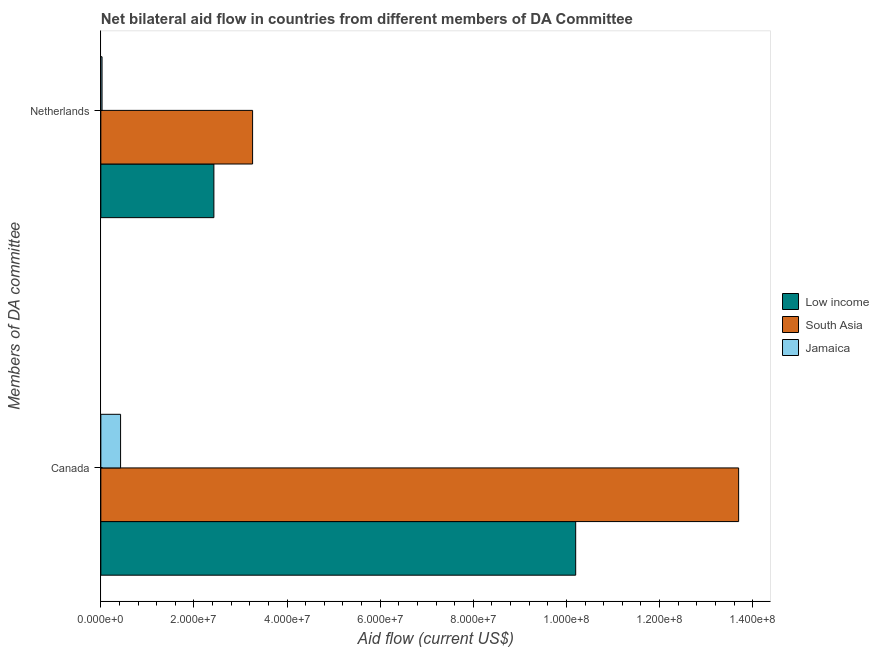How many bars are there on the 2nd tick from the top?
Keep it short and to the point. 3. What is the label of the 2nd group of bars from the top?
Your answer should be compact. Canada. What is the amount of aid given by netherlands in Jamaica?
Your answer should be very brief. 2.60e+05. Across all countries, what is the maximum amount of aid given by netherlands?
Your response must be concise. 3.26e+07. Across all countries, what is the minimum amount of aid given by netherlands?
Offer a terse response. 2.60e+05. In which country was the amount of aid given by netherlands maximum?
Offer a very short reply. South Asia. In which country was the amount of aid given by canada minimum?
Offer a very short reply. Jamaica. What is the total amount of aid given by canada in the graph?
Provide a short and direct response. 2.43e+08. What is the difference between the amount of aid given by canada in South Asia and that in Low income?
Provide a succinct answer. 3.50e+07. What is the difference between the amount of aid given by netherlands in Low income and the amount of aid given by canada in Jamaica?
Your answer should be compact. 2.00e+07. What is the average amount of aid given by canada per country?
Provide a short and direct response. 8.11e+07. What is the difference between the amount of aid given by netherlands and amount of aid given by canada in Jamaica?
Offer a very short reply. -3.98e+06. What is the ratio of the amount of aid given by netherlands in Low income to that in South Asia?
Keep it short and to the point. 0.75. Is the amount of aid given by netherlands in Jamaica less than that in South Asia?
Ensure brevity in your answer.  Yes. How many countries are there in the graph?
Your answer should be compact. 3. Are the values on the major ticks of X-axis written in scientific E-notation?
Provide a succinct answer. Yes. Does the graph contain grids?
Your answer should be compact. No. Where does the legend appear in the graph?
Your answer should be very brief. Center right. How are the legend labels stacked?
Ensure brevity in your answer.  Vertical. What is the title of the graph?
Your response must be concise. Net bilateral aid flow in countries from different members of DA Committee. Does "Arab World" appear as one of the legend labels in the graph?
Offer a very short reply. No. What is the label or title of the Y-axis?
Ensure brevity in your answer.  Members of DA committee. What is the Aid flow (current US$) in Low income in Canada?
Ensure brevity in your answer.  1.02e+08. What is the Aid flow (current US$) of South Asia in Canada?
Offer a very short reply. 1.37e+08. What is the Aid flow (current US$) of Jamaica in Canada?
Your answer should be compact. 4.24e+06. What is the Aid flow (current US$) of Low income in Netherlands?
Ensure brevity in your answer.  2.43e+07. What is the Aid flow (current US$) in South Asia in Netherlands?
Offer a terse response. 3.26e+07. Across all Members of DA committee, what is the maximum Aid flow (current US$) of Low income?
Keep it short and to the point. 1.02e+08. Across all Members of DA committee, what is the maximum Aid flow (current US$) of South Asia?
Offer a terse response. 1.37e+08. Across all Members of DA committee, what is the maximum Aid flow (current US$) of Jamaica?
Provide a succinct answer. 4.24e+06. Across all Members of DA committee, what is the minimum Aid flow (current US$) of Low income?
Give a very brief answer. 2.43e+07. Across all Members of DA committee, what is the minimum Aid flow (current US$) of South Asia?
Provide a short and direct response. 3.26e+07. Across all Members of DA committee, what is the minimum Aid flow (current US$) of Jamaica?
Your response must be concise. 2.60e+05. What is the total Aid flow (current US$) in Low income in the graph?
Keep it short and to the point. 1.26e+08. What is the total Aid flow (current US$) of South Asia in the graph?
Make the answer very short. 1.70e+08. What is the total Aid flow (current US$) of Jamaica in the graph?
Make the answer very short. 4.50e+06. What is the difference between the Aid flow (current US$) in Low income in Canada and that in Netherlands?
Provide a succinct answer. 7.77e+07. What is the difference between the Aid flow (current US$) in South Asia in Canada and that in Netherlands?
Provide a short and direct response. 1.04e+08. What is the difference between the Aid flow (current US$) of Jamaica in Canada and that in Netherlands?
Give a very brief answer. 3.98e+06. What is the difference between the Aid flow (current US$) in Low income in Canada and the Aid flow (current US$) in South Asia in Netherlands?
Offer a terse response. 6.94e+07. What is the difference between the Aid flow (current US$) of Low income in Canada and the Aid flow (current US$) of Jamaica in Netherlands?
Offer a very short reply. 1.02e+08. What is the difference between the Aid flow (current US$) of South Asia in Canada and the Aid flow (current US$) of Jamaica in Netherlands?
Offer a very short reply. 1.37e+08. What is the average Aid flow (current US$) in Low income per Members of DA committee?
Ensure brevity in your answer.  6.31e+07. What is the average Aid flow (current US$) of South Asia per Members of DA committee?
Ensure brevity in your answer.  8.48e+07. What is the average Aid flow (current US$) in Jamaica per Members of DA committee?
Offer a terse response. 2.25e+06. What is the difference between the Aid flow (current US$) of Low income and Aid flow (current US$) of South Asia in Canada?
Your response must be concise. -3.50e+07. What is the difference between the Aid flow (current US$) of Low income and Aid flow (current US$) of Jamaica in Canada?
Offer a terse response. 9.77e+07. What is the difference between the Aid flow (current US$) of South Asia and Aid flow (current US$) of Jamaica in Canada?
Ensure brevity in your answer.  1.33e+08. What is the difference between the Aid flow (current US$) of Low income and Aid flow (current US$) of South Asia in Netherlands?
Offer a very short reply. -8.31e+06. What is the difference between the Aid flow (current US$) of Low income and Aid flow (current US$) of Jamaica in Netherlands?
Offer a terse response. 2.40e+07. What is the difference between the Aid flow (current US$) in South Asia and Aid flow (current US$) in Jamaica in Netherlands?
Ensure brevity in your answer.  3.23e+07. What is the ratio of the Aid flow (current US$) in Low income in Canada to that in Netherlands?
Ensure brevity in your answer.  4.2. What is the ratio of the Aid flow (current US$) of South Asia in Canada to that in Netherlands?
Make the answer very short. 4.2. What is the ratio of the Aid flow (current US$) in Jamaica in Canada to that in Netherlands?
Your answer should be compact. 16.31. What is the difference between the highest and the second highest Aid flow (current US$) of Low income?
Ensure brevity in your answer.  7.77e+07. What is the difference between the highest and the second highest Aid flow (current US$) in South Asia?
Ensure brevity in your answer.  1.04e+08. What is the difference between the highest and the second highest Aid flow (current US$) of Jamaica?
Your answer should be compact. 3.98e+06. What is the difference between the highest and the lowest Aid flow (current US$) in Low income?
Give a very brief answer. 7.77e+07. What is the difference between the highest and the lowest Aid flow (current US$) of South Asia?
Make the answer very short. 1.04e+08. What is the difference between the highest and the lowest Aid flow (current US$) of Jamaica?
Ensure brevity in your answer.  3.98e+06. 